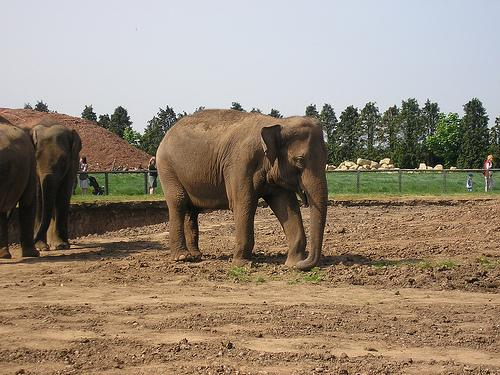Mention one activity that the people in the image are engaged in. A kid and an adult are watching the elephants in the image. What are some observable features of the ground in the image? The ground is dirt, has small rocks, and grass, and is brown in color. How many individuals are standing in the image? There are two people standing, a kid and an adult, along with a woman in a red jacket. Comment on the sentiment expressed in the image. The image has a positive and calm sentiment with elephants, people watching them, and a natural setting with trees and grass. Count the number of elephants in the image. There are two elephants standing together in the image. What is the color of the elephant's eyes? The color of the elephant's eyes cannot be determined from the bounding box information. Provide a short description of the elephant's ear and trunk. The elephant has a big floppy ear and a long trunk. What can you tell about the trees in the image? The trees are tall, green, and have leaves in the image. List all the colors mentioned in the image. Grey, green, blue, white, brown, and red. What does the sky look like in the image? The sky is blue with clouds in it, appearing blue and white. "Have you noticed the pink flowers growing in the patch of green grass?" This instruction is misleading because there are no mentions of pink flowers in the image. Grass is mentioned, but only in connection with dirt. The question form makes the viewer more likely to search for the non-existent pink flowers, and the specific language draws attention away from other, actually-existing objects. "Behind the elephants, a small waterfall trickles into a pond." This instruction is misleading because there are no mentions of a waterfall or pond in the image. Elephants are mentioned frequently, but not in relation to any water features. The declarative sentence misleads the viewer into thinking there's a definite water feature in the image. "Can you spot the purple butterfly floating near the trees?" This instruction is misleading because there are no mentions of a purple butterfly in the image. The objects listed mostly involve elephants, dirt, trees, rocks, and people, but there's nothing about butterflies. Also, the use of a question makes the viewer actively search for something that doesn't exist in the image. "Observe the cute cat sleeping beside the elephant's leg." This instruction is misleading because there are no mentions of a cat in the image. Elephants and their legs are mentioned, but not in conjunction with any other animals. The descriptive language used in the sentence makes the non-existent cat more appealing to look for, making it more misleading. "The apple tree in the background is full of delicious red apples." No, it's not mentioned in the image. "The flying bird in the sky is eating a small insect." This instruction is misleading because there are no mentions of a bird, flying or otherwise, in the image. The sky is mentioned, but only in terms of its color and the presence of clouds. The declarative sentence makes it seem like there's a definite bird in the picture, which there isn't. 